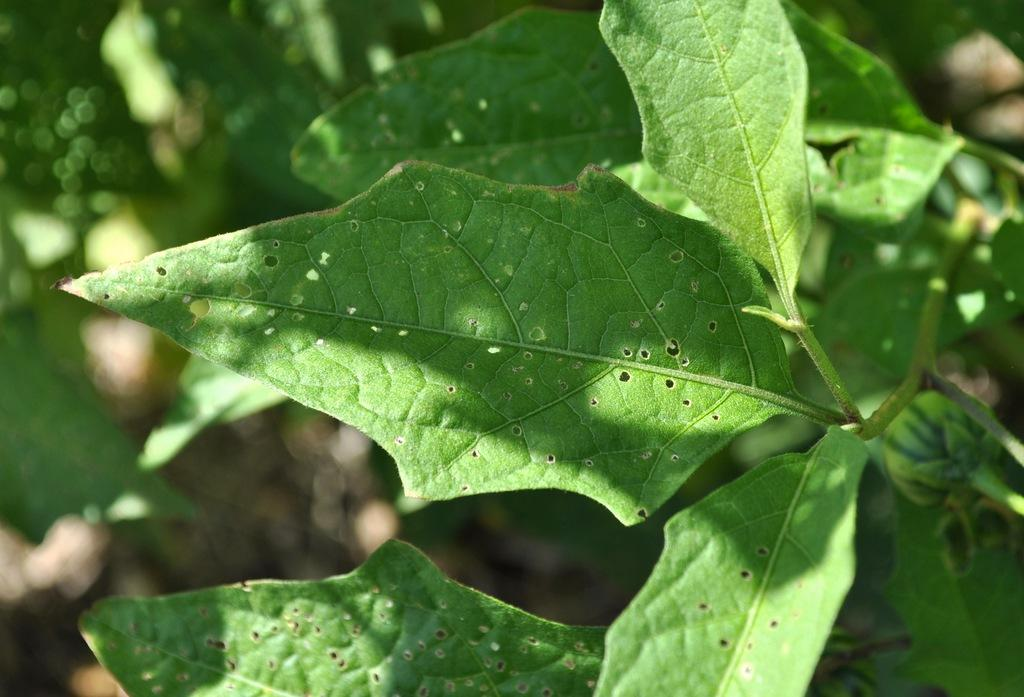What type of living organisms can be seen in the image? Plants can be seen in the image. Can you describe the background of the image? The background of the image is blurred. Where is the wren sitting on the throne in the image? There is no wren or throne present in the image; it only features plants and a blurred background. 